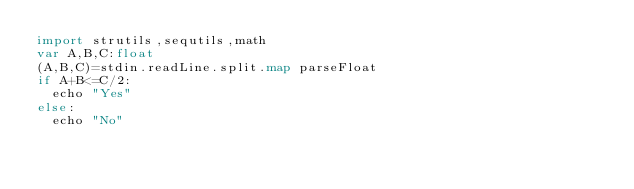Convert code to text. <code><loc_0><loc_0><loc_500><loc_500><_Nim_>import strutils,sequtils,math
var A,B,C:float
(A,B,C)=stdin.readLine.split.map parseFloat
if A+B<=C/2:
  echo "Yes"
else:
  echo "No"</code> 